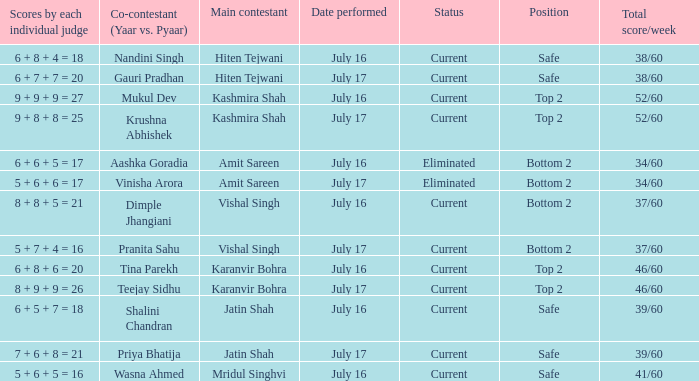What position did the team with the total score of 41/60 get? Safe. 